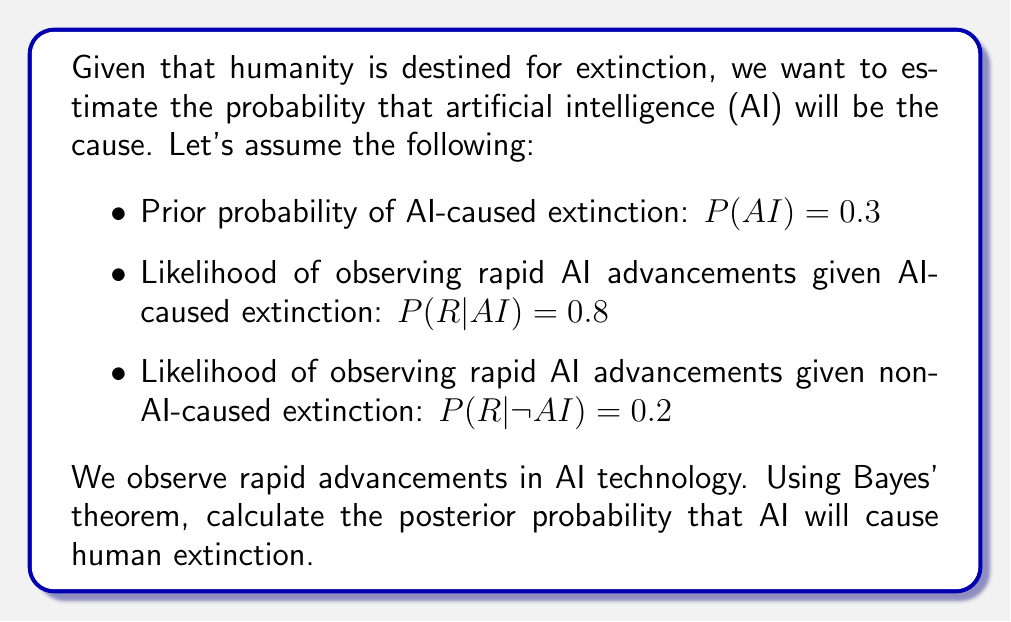What is the answer to this math problem? To solve this problem, we'll use Bayes' theorem:

$$P(AI|R) = \frac{P(R|AI) \cdot P(AI)}{P(R)}$$

Where:
- $P(AI|R)$ is the posterior probability of AI-caused extinction given rapid AI advancements
- $P(R|AI)$ is the likelihood of observing rapid AI advancements given AI-caused extinction
- $P(AI)$ is the prior probability of AI-caused extinction
- $P(R)$ is the total probability of observing rapid AI advancements

We need to calculate $P(R)$ using the law of total probability:

$$P(R) = P(R|AI) \cdot P(AI) + P(R|\neg AI) \cdot P(\neg AI)$$

First, calculate $P(\neg AI)$:
$$P(\neg AI) = 1 - P(AI) = 1 - 0.3 = 0.7$$

Now, calculate $P(R)$:
$$P(R) = 0.8 \cdot 0.3 + 0.2 \cdot 0.7 = 0.24 + 0.14 = 0.38$$

Finally, apply Bayes' theorem:

$$P(AI|R) = \frac{0.8 \cdot 0.3}{0.38} = \frac{0.24}{0.38} \approx 0.6316$$
Answer: The posterior probability that AI will cause human extinction, given the observation of rapid AI advancements, is approximately 0.6316 or 63.16%. 